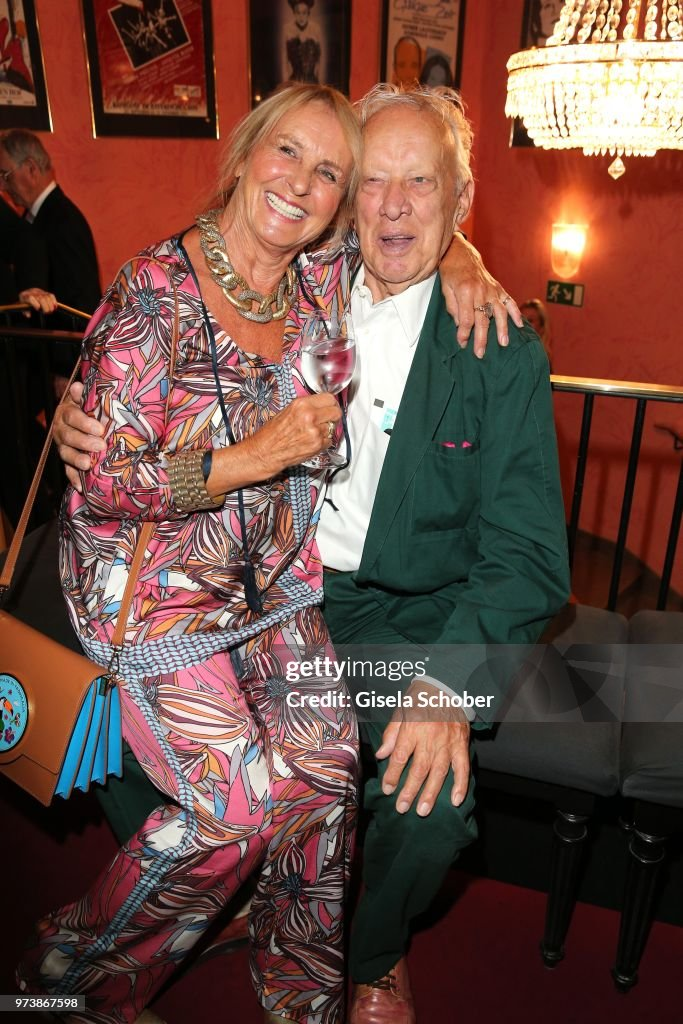Considering the expressions and body language of the couple, what can be inferred about their relationship or the mood of the occasion? The couple's expressions and body language convey a deep sense of closeness and affection. The woman's broad, genuine smile and the man's relaxed demeanor, with his arm comfortably draped around her, indicate a warm and intimate relationship. Both of them are visibly enjoying the moment, suggesting a joyful and convivial atmosphere. The setting, adorned with vibrant decorations, and their casual yet stylish attire hint at a social gathering or celebration, likely filled with friends and loved ones, where the primary goal is to enjoy each other's company and celebrate joyous moments. 